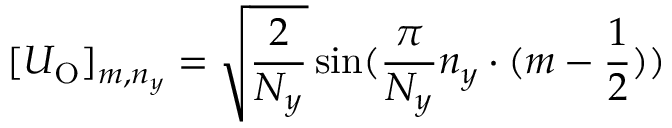Convert formula to latex. <formula><loc_0><loc_0><loc_500><loc_500>[ U _ { O } ] _ { m , n _ { y } } = \sqrt { \frac { 2 } { N _ { y } } } \sin ( \frac { \pi } { N _ { y } } n _ { y } \cdot ( m - \frac { 1 } { 2 } ) )</formula> 